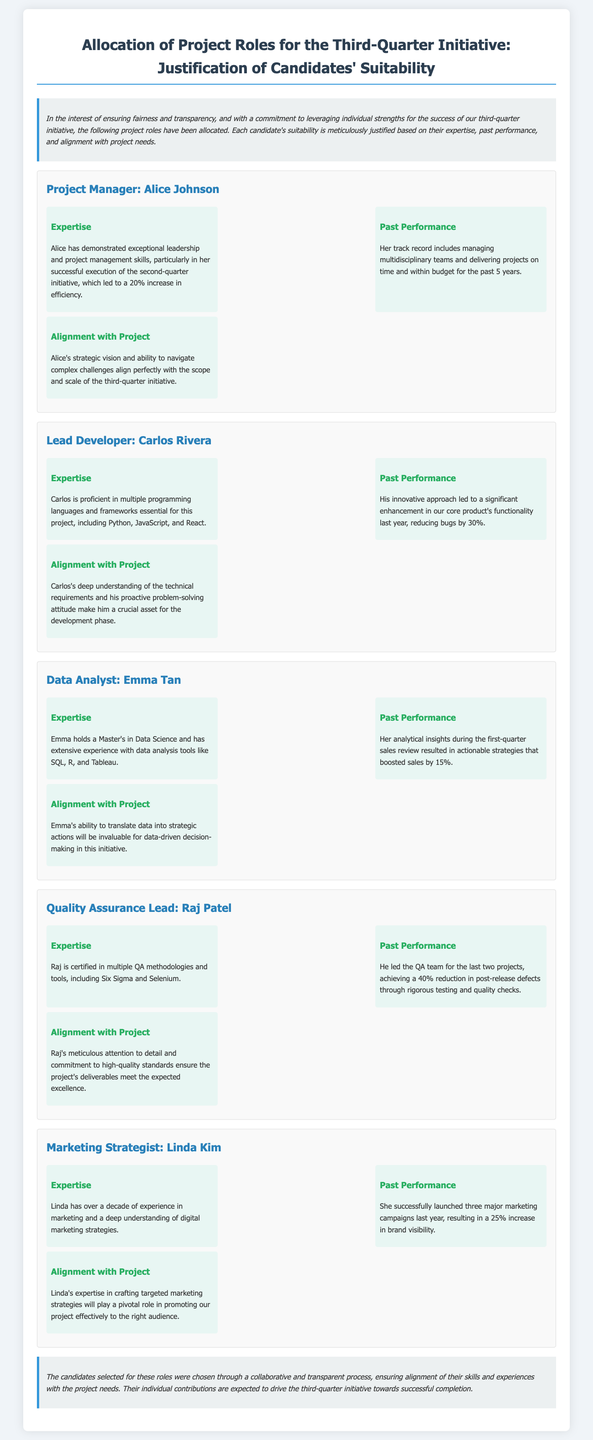What is the title of the document? The title of the document is stated at the beginning of the declaration.
Answer: Allocation of Project Roles for the Third-Quarter Initiative: Justification of Candidates' Suitability Who is the Project Manager? The document specifies the role and candidate for the project manager.
Answer: Alice Johnson What percentage increase in efficiency did Alice achieve in the second quarter? The document mentions a specific increase in efficiency due to Alice's execution of the initiative.
Answer: 20% Which programming languages is Carlos proficient in? The document lists the programming languages essential for the project that Carlos is proficient in.
Answer: Python, JavaScript, and React What was the result of Emma's analytical insights during the first-quarter sales review? The document specifies the impact of Emma's analysis on sales.
Answer: Boosted sales by 15% How many years of experience does Linda have in marketing? The document explicitly states Linda's years of experience in the marketing field.
Answer: Over a decade What is Raj's certification in? The document indicates the specific certifications Raj holds.
Answer: Multiple QA methodologies and tools What was the reduction in post-release defects achieved by Raj's QA team? The document provides a specific percentage related to the reduction of defects.
Answer: 40% What type of document is this? The purpose and structure of the content signify its classification.
Answer: Declaration 